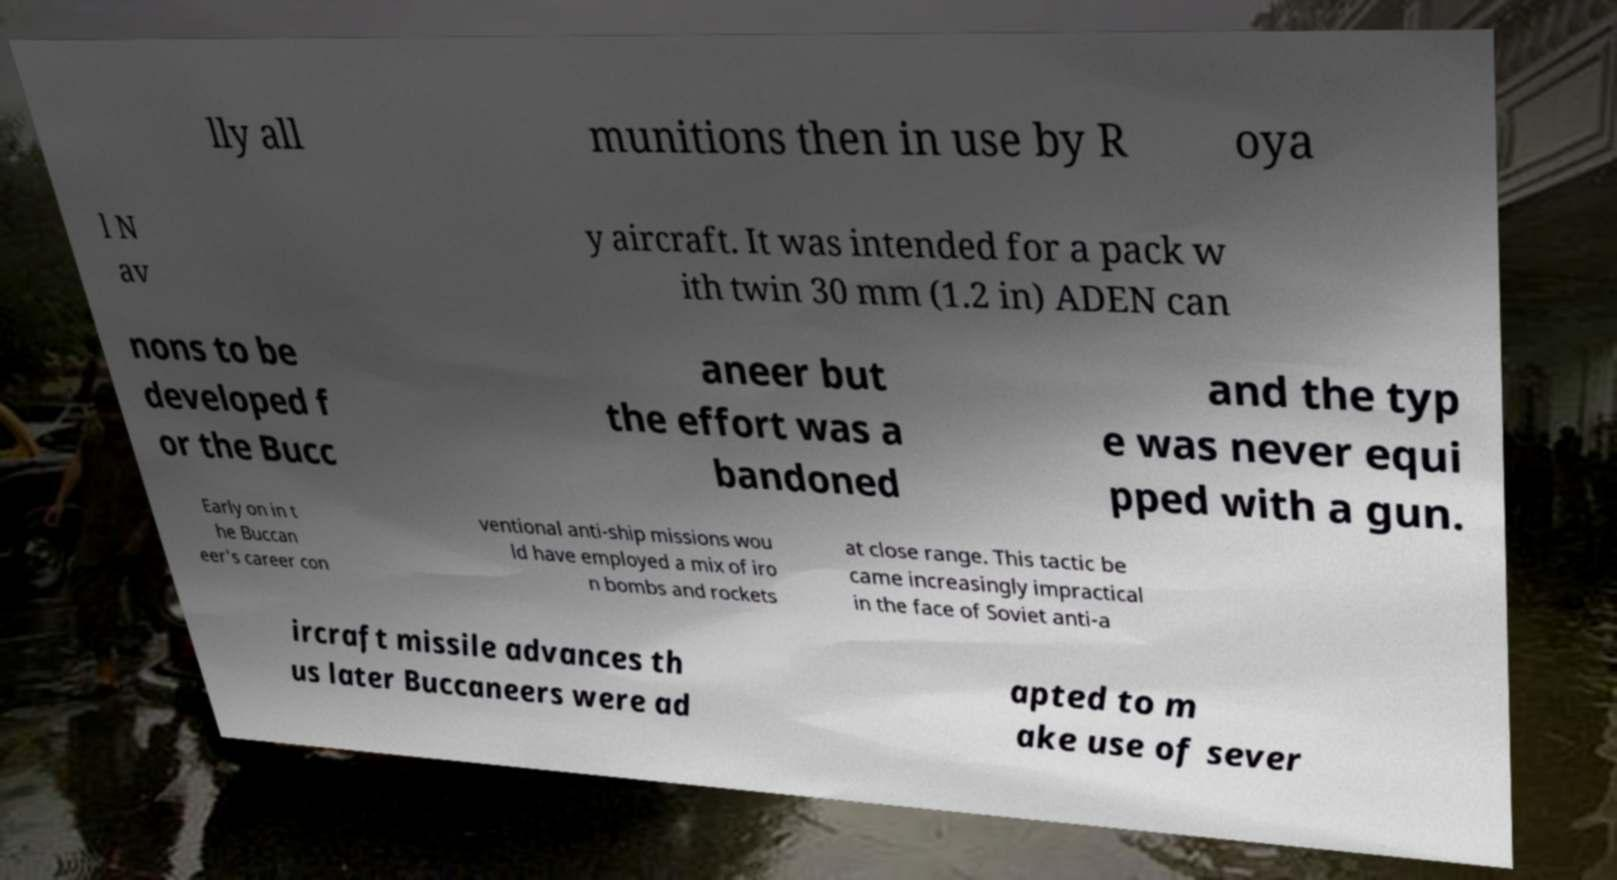What messages or text are displayed in this image? I need them in a readable, typed format. lly all munitions then in use by R oya l N av y aircraft. It was intended for a pack w ith twin 30 mm (1.2 in) ADEN can nons to be developed f or the Bucc aneer but the effort was a bandoned and the typ e was never equi pped with a gun. Early on in t he Buccan eer's career con ventional anti-ship missions wou ld have employed a mix of iro n bombs and rockets at close range. This tactic be came increasingly impractical in the face of Soviet anti-a ircraft missile advances th us later Buccaneers were ad apted to m ake use of sever 